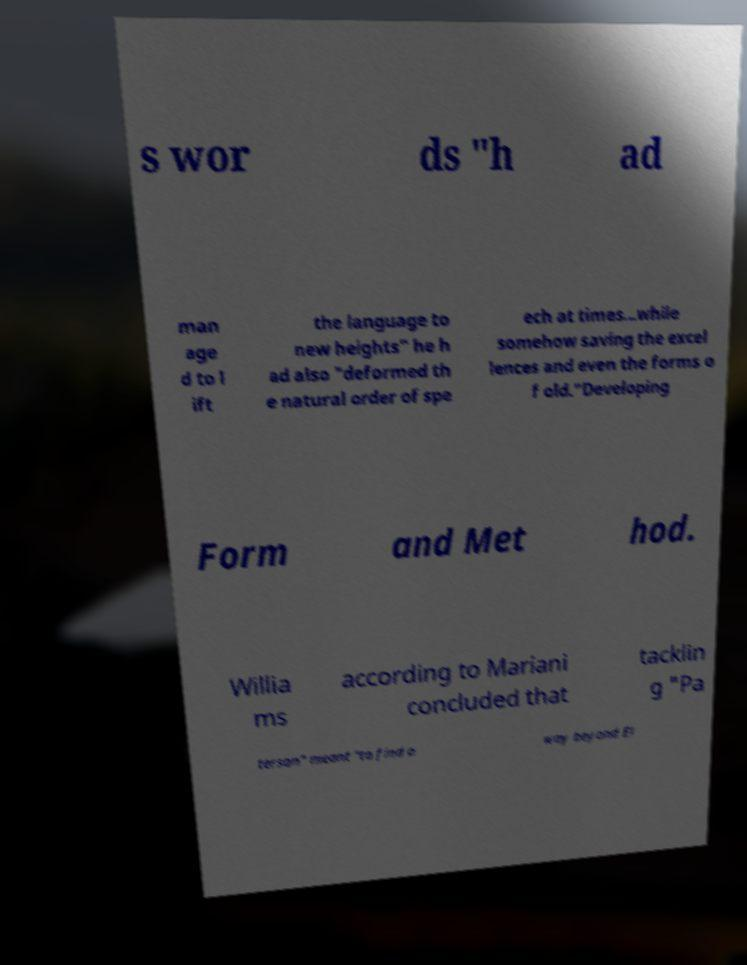For documentation purposes, I need the text within this image transcribed. Could you provide that? s wor ds "h ad man age d to l ift the language to new heights" he h ad also "deformed th e natural order of spe ech at times...while somehow saving the excel lences and even the forms o f old."Developing Form and Met hod. Willia ms according to Mariani concluded that tacklin g "Pa terson" meant "to find a way beyond El 